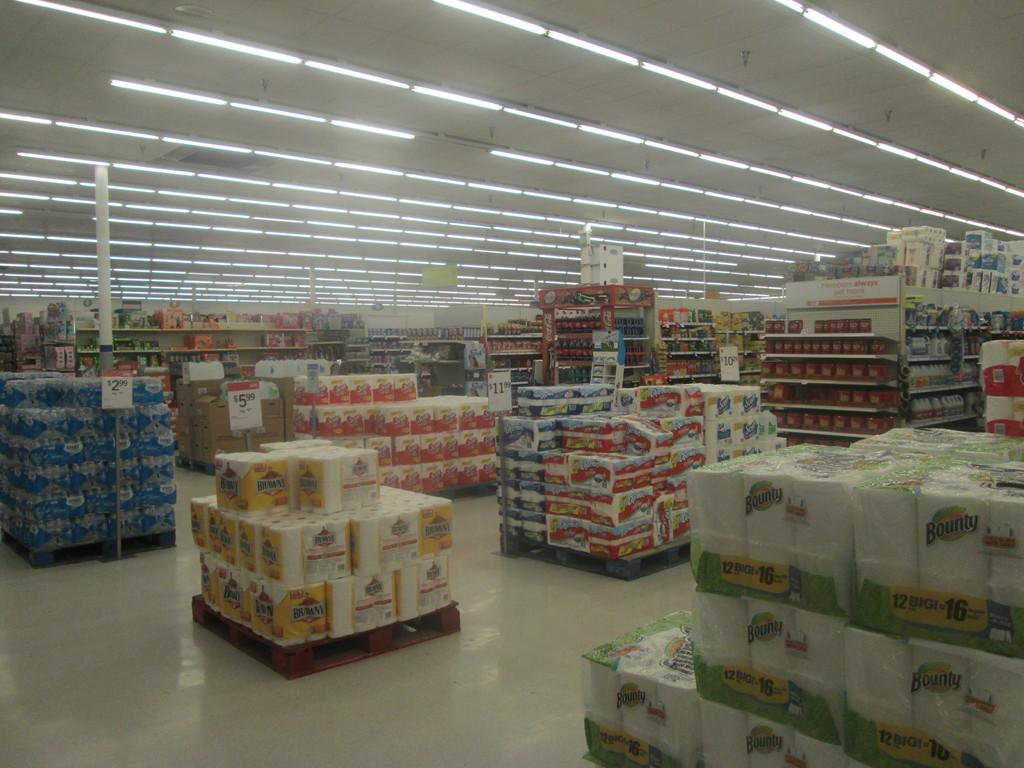<image>
Describe the image concisely. Packages of products including Brawny and Bounty paper towels are stack in a store for sale. 